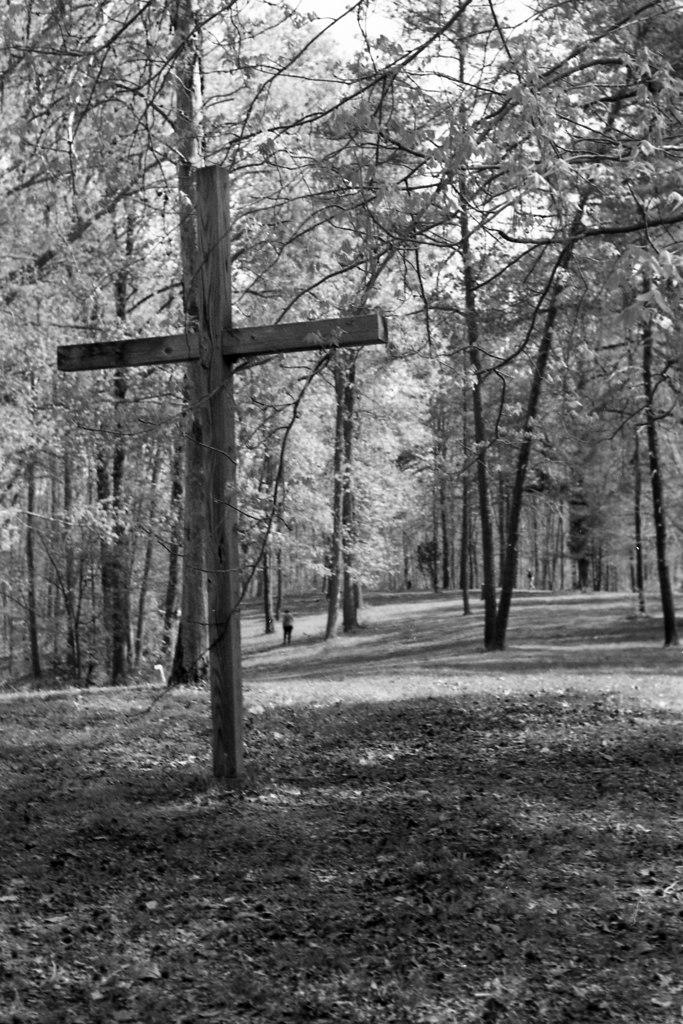What type of vegetation can be seen in the image? There are trees in the image. What is present on the ground beneath the trees? Dry leaves are present on the ground. What symbol can be seen in the image? There is a cross symbol in the image. Can you describe the person in the image? A person is visible in the image. What is visible in the background of the image? The sky is visible in the image. What type of expansion is taking place in the image? There is no expansion present in the image. What body part of the person is visible in the image? The facts provided do not specify any body parts of the person, so we cannot determine which ones are visible. 